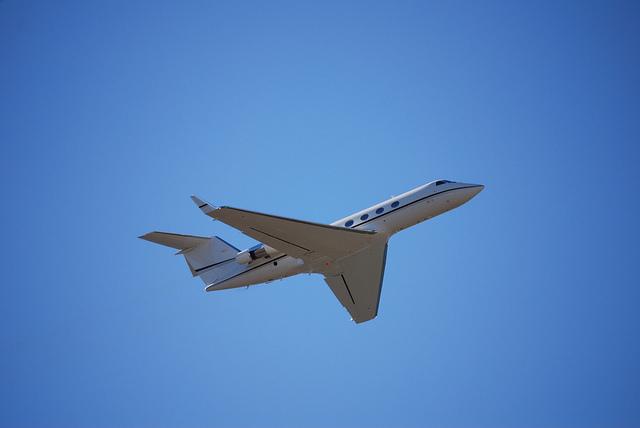Is this a fighter jet?
Keep it brief. No. What color is the sky?
Give a very brief answer. Blue. What direction is the plane flying?
Be succinct. Right. How many tires can you see in this photo?
Give a very brief answer. 0. What color are the circles?
Be succinct. Blue. Is the plane flying?
Concise answer only. Yes. The plane is from the us navy?
Keep it brief. No. Is the landing gear lowered?
Quick response, please. No. What color is the jet?
Answer briefly. White. What is the pattern on the plane's body?
Give a very brief answer. Stripe. 